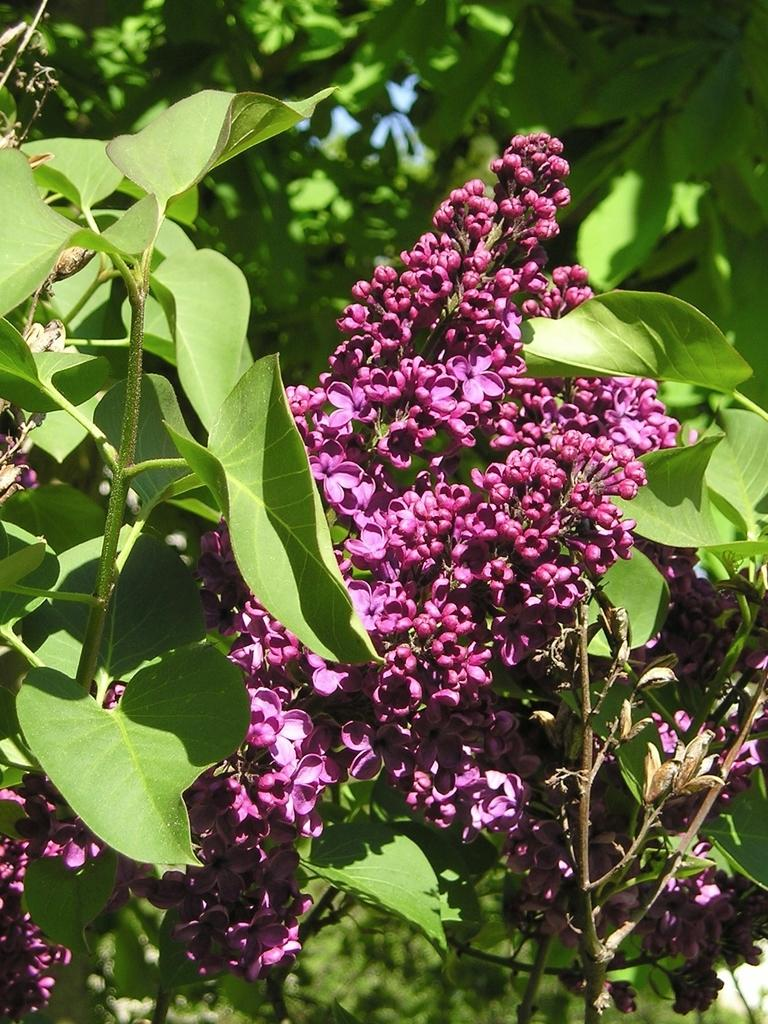What type of flora can be seen in the image? There are flowers and plants in the image. What color are the flowers in the image? The flowers are purple. What color are the plants in the image? The plants are green. What can be seen in the background of the image? The sky is visible in the background of the image. What color is the sky in the image? The sky is blue. What type of bottle is visible in the image? There is no bottle present in the image. 